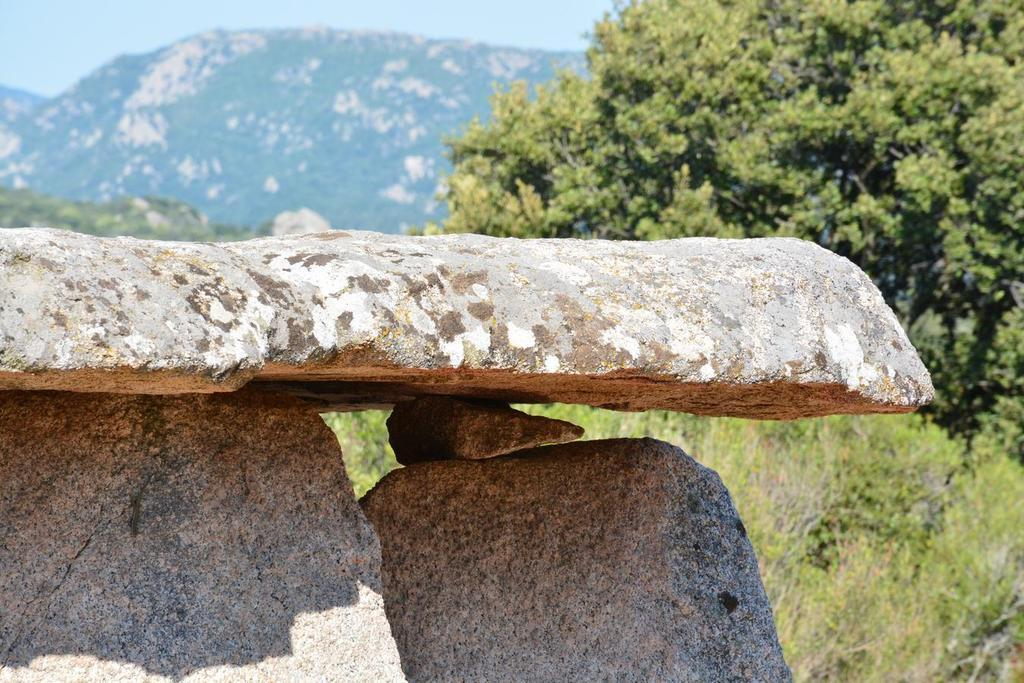What type of natural elements can be seen on the left side of the image? There are stones on the left side of the image. What type of vegetation is present on the ground behind the stones? There is grass on the ground behind the stones. What other natural elements can be seen in the image? There are trees in the image. What can be seen in the background of the image? There is a hill with trees in the background of the image. What type of music is playing in the background of the image? There is no music present in the image; it is a still image of natural elements. How many stones are there in the image? The number of stones cannot be determined from the image alone, as it only shows that there are stones on the left side. 